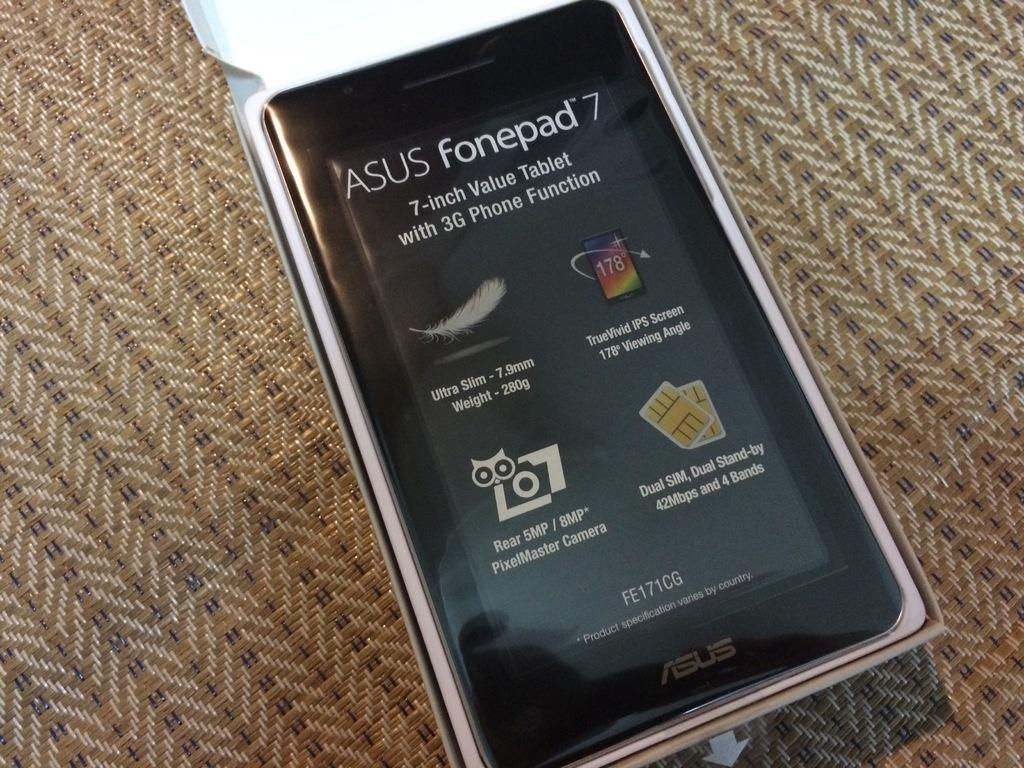<image>
Present a compact description of the photo's key features. An Asus Fonepad 7 model tablet sits on a brown and white woven mat. 